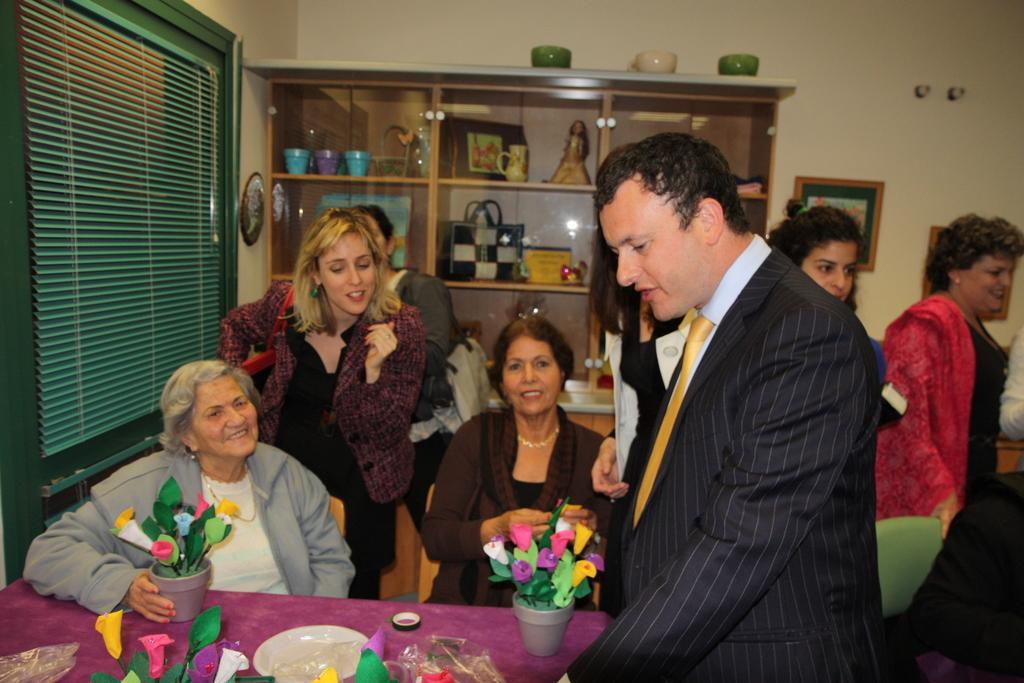Could you give a brief overview of what you see in this image? In this image there is a table at the bottom. There is a window blind on the left corner. There are flower vases and plates placed on the table, there are chairs and people in the foreground. There are people and frames on the wall in the right corner. There is a cupboard with objects on it and there is a wall in the background. 